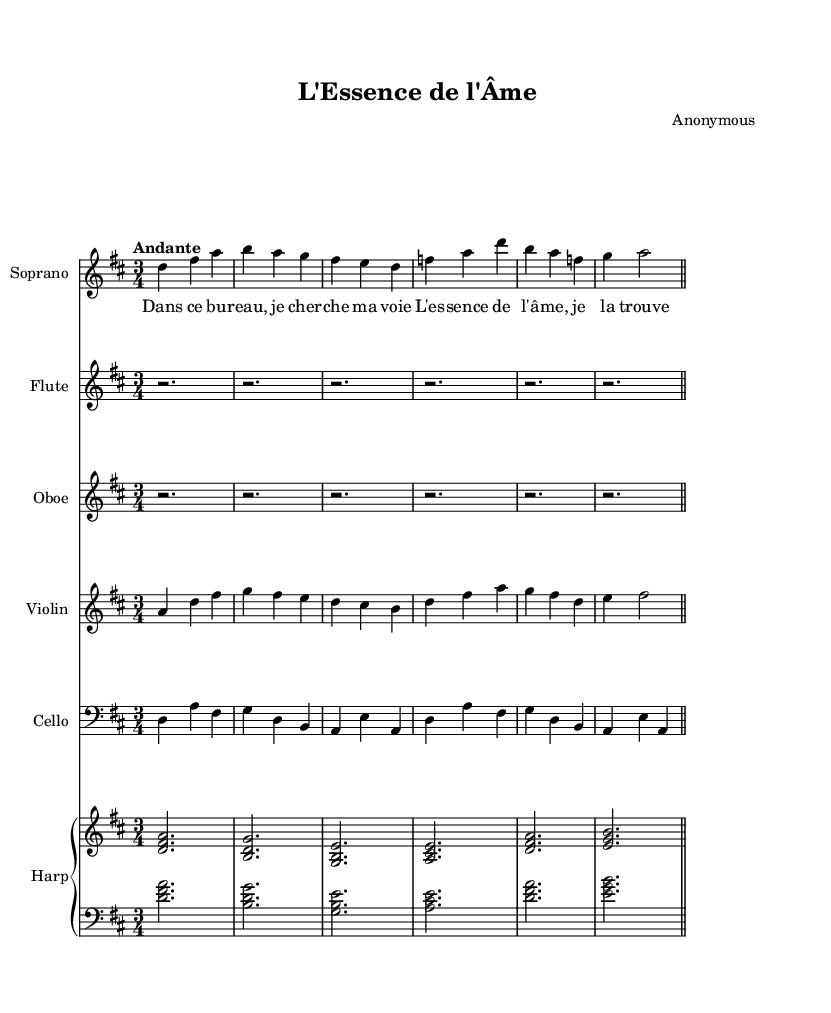What is the key signature of this music? The key signature indicated in the global settings is D major, which has two sharps: F# and C#.
Answer: D major What is the time signature of this piece? The global settings of the music specify a time signature of 3/4, which means there are three beats per measure.
Answer: 3/4 What is the tempo marking for this music? The tempo marking in the global settings is "Andante," which typically means a moderate walking pace.
Answer: Andante How many measures are there in the soprano voice part? Counting the measures in the soprano part, we see there are a total of 6 measures.
Answer: 6 What instrument plays a 3/4 rhythm in this score? The time signature indicates that the music should be played in 3/4 rhythm, and the soprano voice part demonstrates this clearly.
Answer: Soprano What is the theme explored in the lyrics? The lyrics suggest a journey of self-discovery and finding one's essence, specifically through the motif of scent, as reflected in the first verse.
Answer: Self-discovery What does the lyrical phrase "L'essence de l'âme" translate to in English? The phrase translates to "The essence of the soul," highlighting the central theme of the opera.
Answer: The essence of the soul 